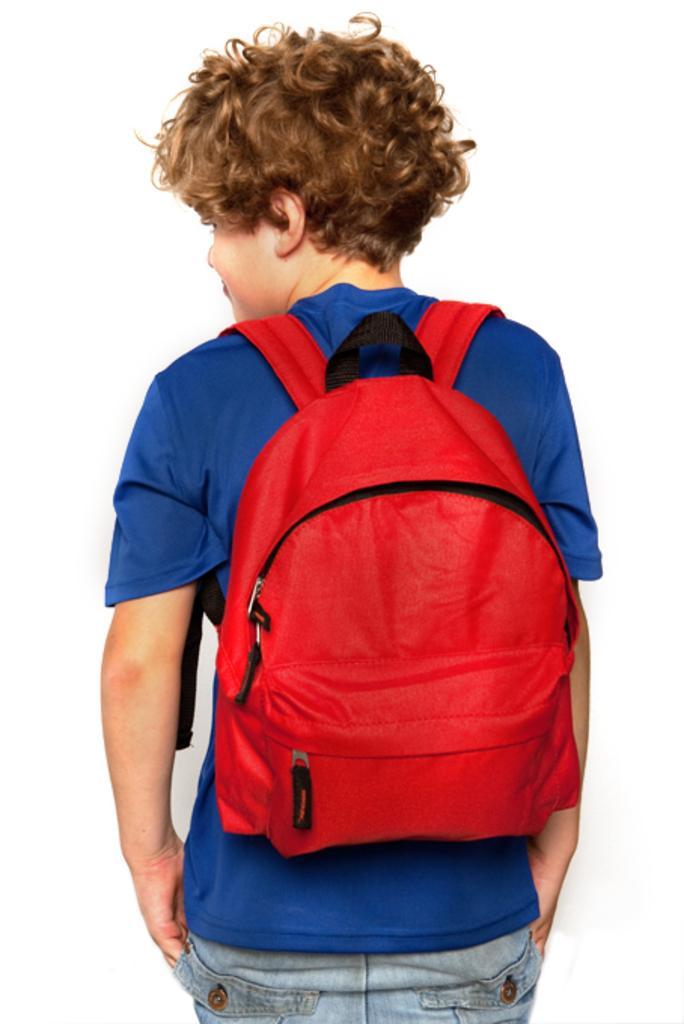In one or two sentences, can you explain what this image depicts? In this picture we can see a boy wore blue color T-Shirt carrying bag to his back. 